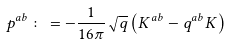Convert formula to latex. <formula><loc_0><loc_0><loc_500><loc_500>p ^ { a b } \colon = - \frac { 1 } { 1 6 \pi } \sqrt { q } \left ( K ^ { a b } - q ^ { a b } K \right )</formula> 